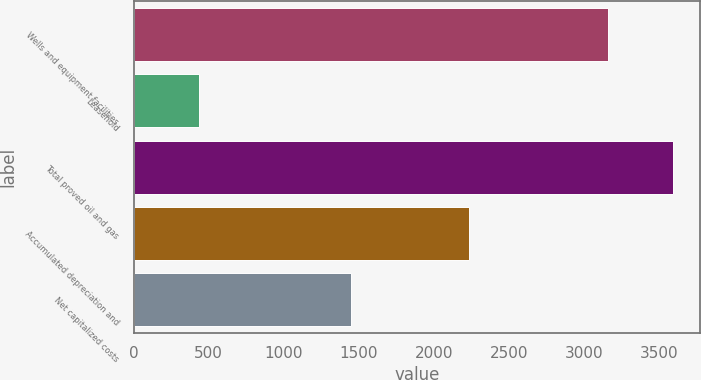Convert chart to OTSL. <chart><loc_0><loc_0><loc_500><loc_500><bar_chart><fcel>Wells and equipment facilities<fcel>Leasehold<fcel>Total proved oil and gas<fcel>Accumulated depreciation and<fcel>Net capitalized costs<nl><fcel>3158.8<fcel>433.1<fcel>3591.9<fcel>2235.4<fcel>1444.8<nl></chart> 